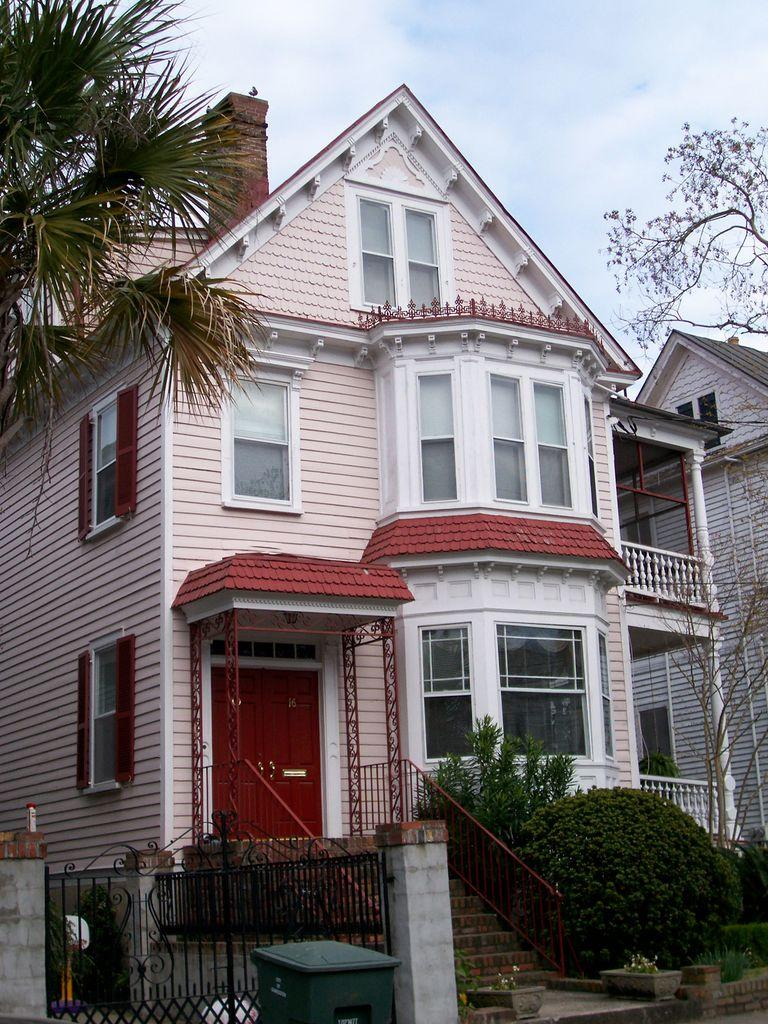What type of structures can be seen in the image? There are buildings in the image. What type of vegetation is present in the image? There are trees and plants in the image. Can you describe the house plants in the image? There are house plants in the image. What else can be seen in the image besides the structures and vegetation? There are objects in the image. What is visible in the background of the image? The sky is visible in the background of the image. What type of reaction can be seen in the image? There is no reaction visible in the image; it is a still image of buildings, trees, plants, house plants, and objects. Is there a sink visible in the image? There is no sink present in the image. 